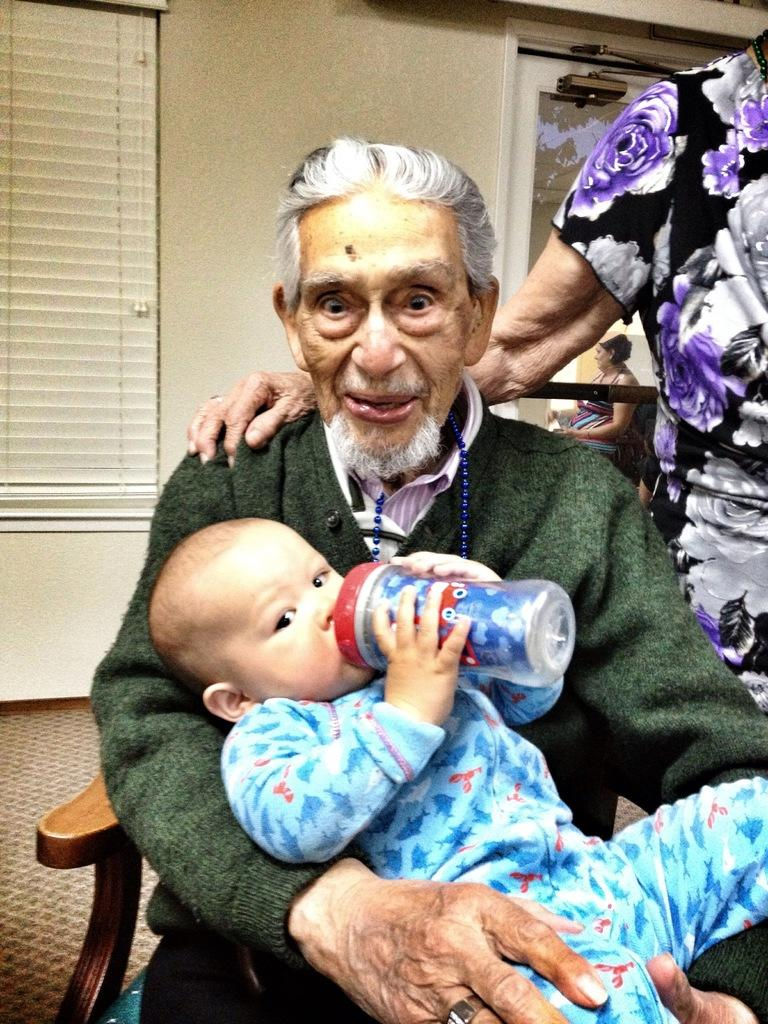What is the man in the image doing? The man is sitting on a wooden chair and holding a baby boy in his hands. Who else is present in the image? There is a woman standing on the right side of the image. What book is the baby reading in the image? There is no book present in the image, and the baby is too young to read. 